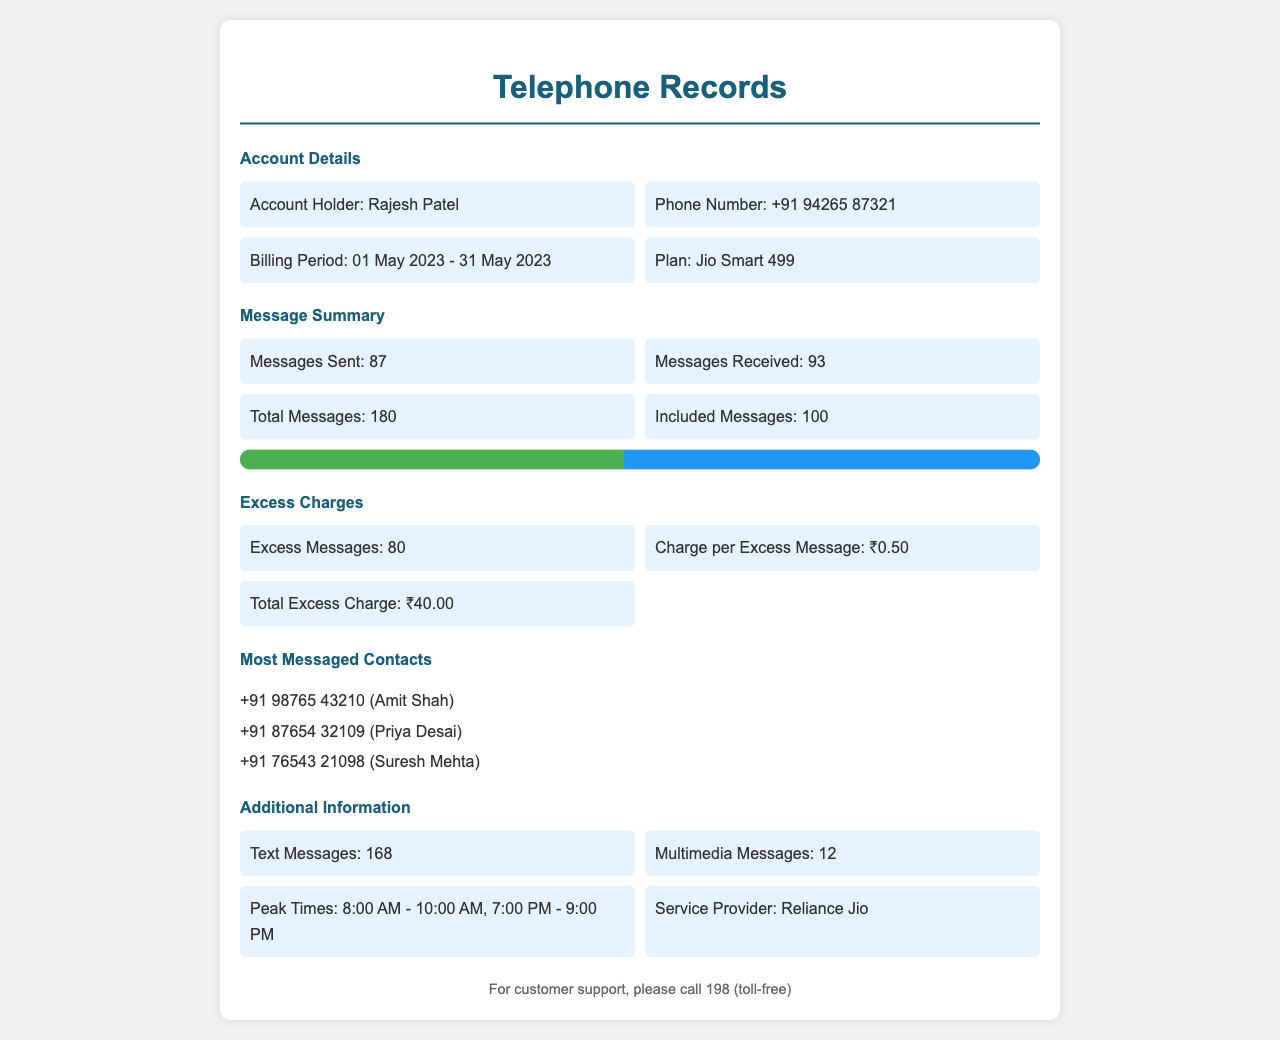What is the account holder's name? The account holder's name is displayed in the account details section of the document.
Answer: Rajesh Patel How many messages were sent? The number of messages sent is listed in the message summary section.
Answer: 87 What is the total number of messages? The total number of messages is found by summing sent and received messages in the message summary section.
Answer: 180 What is the charge per excess message? The charge for each excess message is specified in the excess charges section.
Answer: ₹0.50 How many excess messages were there? The total number of excess messages is noted in the excess charges section of the document.
Answer: 80 What is the total excess charge? The total excess charge is calculated based on the number of excess messages and the charge per message.
Answer: ₹40.00 What was the billing period? The billing period is provided in the account details section.
Answer: 01 May 2023 - 31 May 2023 Who is one of the most messaged contacts? The most messaged contacts are listed, and any could be a valid answer.
Answer: Amit Shah How many multimedia messages were sent? The number of multimedia messages is indicated in the additional information section.
Answer: 12 What is the service provider? The service provider is noted in the additional information section of the document.
Answer: Reliance Jio 